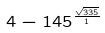<formula> <loc_0><loc_0><loc_500><loc_500>4 - 1 4 5 ^ { \frac { \sqrt { 3 3 5 } } { 1 } }</formula> 